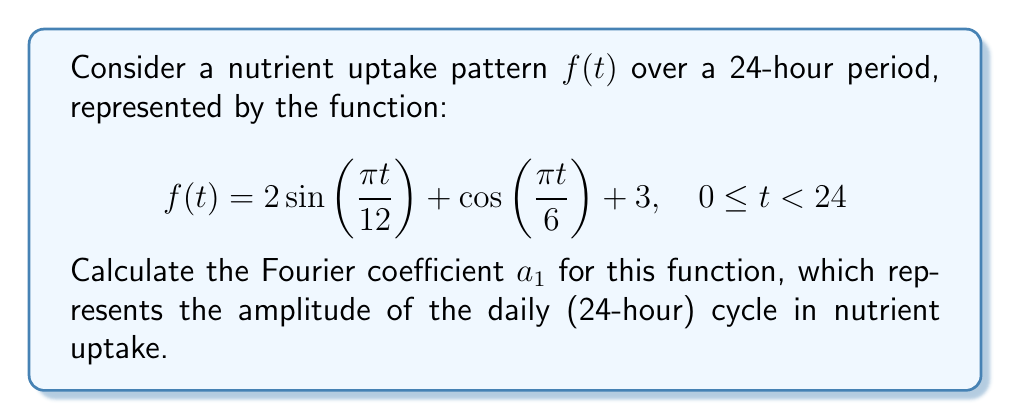Provide a solution to this math problem. To find the Fourier coefficient $a_1$, we need to calculate:

$$a_1 = \frac{1}{12} \int_0^{24} f(t) \cos(\frac{\pi t}{12}) dt$$

Let's break this down step-by-step:

1) Substitute $f(t)$ into the integral:

   $$a_1 = \frac{1}{12} \int_0^{24} (2 \sin(\frac{\pi t}{12}) + \cos(\frac{\pi t}{6}) + 3) \cos(\frac{\pi t}{12}) dt$$

2) Distribute the cosine term:

   $$a_1 = \frac{1}{12} \int_0^{24} (2 \sin(\frac{\pi t}{12})\cos(\frac{\pi t}{12}) + \cos(\frac{\pi t}{6})\cos(\frac{\pi t}{12}) + 3\cos(\frac{\pi t}{12})) dt$$

3) Use trigonometric identities:
   - $\sin A \cos A = \frac{1}{2}\sin(2A)$
   - $\cos A \cos B = \frac{1}{2}[\cos(A-B) + \cos(A+B)]$

   $$a_1 = \frac{1}{12} \int_0^{24} (\sin(\frac{\pi t}{6}) + \frac{1}{2}[\cos(\frac{\pi t}{12}) + \cos(\frac{\pi t}{4})] + 3\cos(\frac{\pi t}{12})) dt$$

4) Integrate each term:
   
   $$a_1 = \frac{1}{12} [-\frac{6}{\pi}\cos(\frac{\pi t}{6}) + \frac{6}{\pi}\sin(\frac{\pi t}{12}) + \frac{3}{\pi}\sin(\frac{\pi t}{4}) + \frac{36}{\pi}\sin(\frac{\pi t}{12})]_0^{24}$$

5) Evaluate at the limits:
   
   $$a_1 = \frac{1}{12} [0 + 0 + 0 + 0] = 0$$

The result is zero because all the sine and cosine terms complete full cycles over the 24-hour period.
Answer: $a_1 = 0$ 